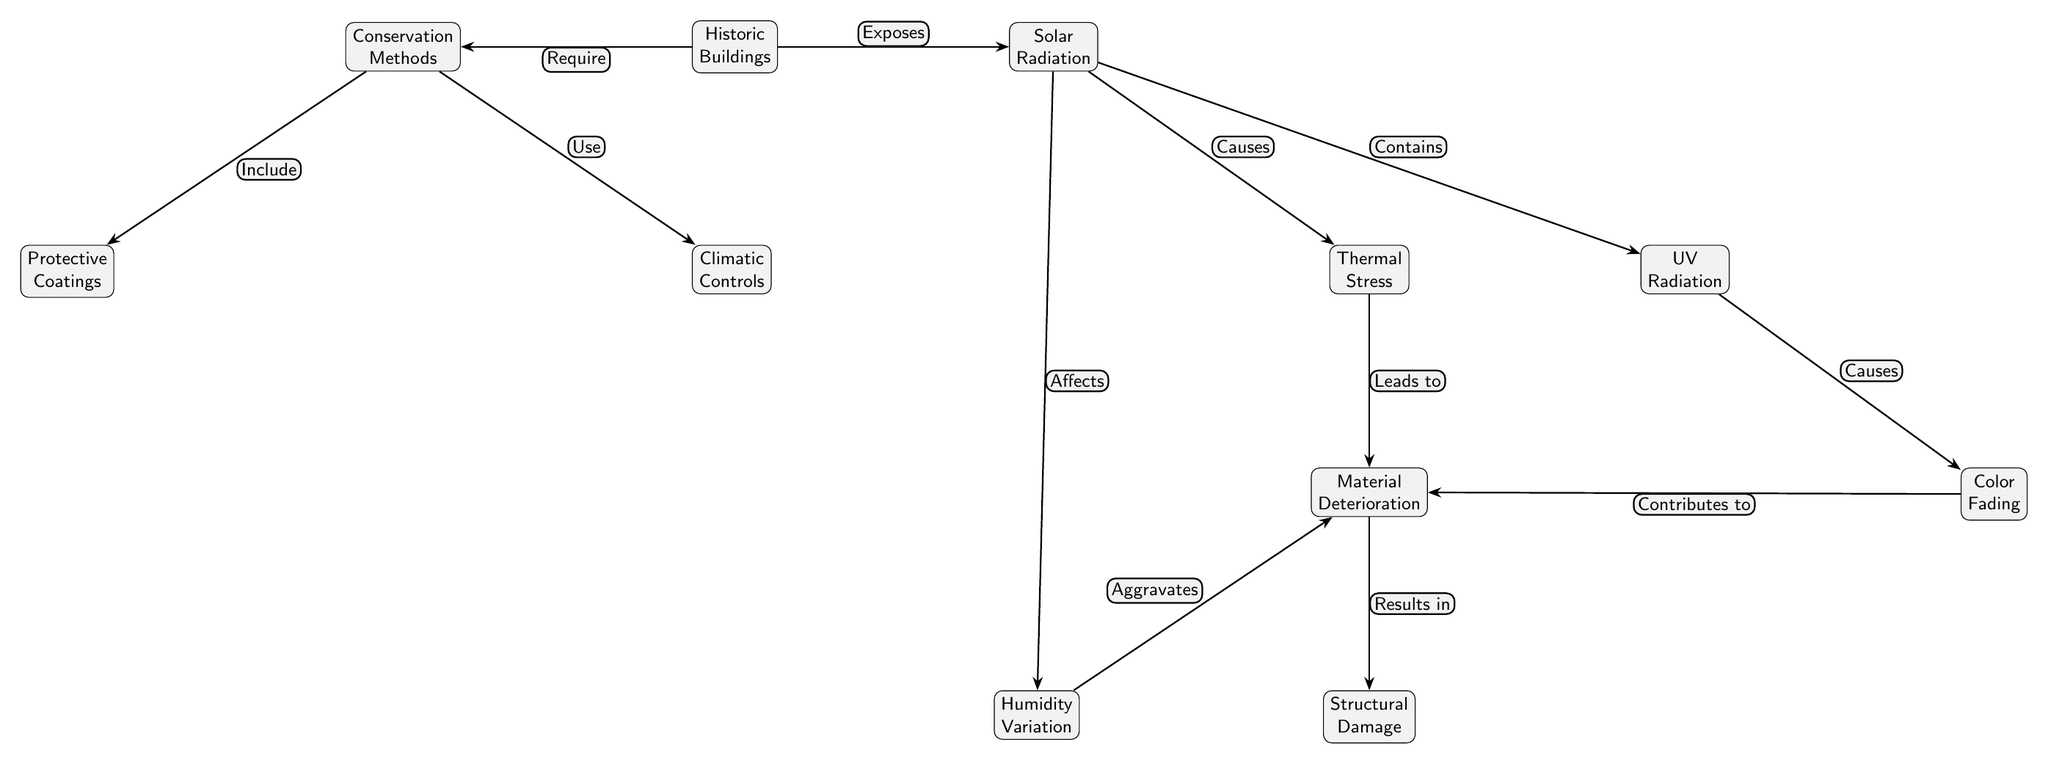What are the two main types of stress caused by solar radiation? The diagram lists thermal stress and UV radiation as the two main types of stress attributed to solar radiation. These are represented as separate nodes connected to the solar radiation node.
Answer: Thermal stress, UV radiation What leads to structural damage? The diagram shows that structural damage results from material deterioration, which is depicted as a node below material deterioration connected with a "Results in" edge label. Material deterioration, notably influenced by thermal stress and humidity variation, leads to structural damage.
Answer: Material deterioration How many conservation methods are shown in the diagram? The diagram presents two conservation methods: protective coatings and climatic controls. These are connected to the conservation methods node with "Include" and "Use" respectively, indicating the means of preservation.
Answer: Two What contributes to material deterioration? According to the diagram, material deterioration is influenced by both humidity variation and color fading. The corresponding edges labeled "Aggravates" and "Contributes to" indicate these relationships to material deterioration.
Answer: Humidity variation, color fading What does solar radiation expose? The diagram describes that solar radiation exposes historic buildings, as shown by the edge labeled "Exposes" connecting the historic buildings and solar radiation nodes. This indicates that historic buildings are directly affected by solar radiation.
Answer: Historic buildings What causes color fading? The diagram explicitly shows that UV radiation causes color fading, as indicated by the edge labeled "Causes" leading from the UV radiation node to the color fading node. This highlights the detrimental effect of UV radiation on the colors of historic buildings.
Answer: UV radiation What is one way to mitigate the impact of solar radiation on historic buildings? The diagram indicates that conservation methods are required for historic buildings to mitigate the effects of solar radiation, which suggests that implementing protective measures is essential for preservation.
Answer: Conservation methods Which factor is shown to aggravate material deterioration? The diagram indicates that humidity variation aggravates material deterioration, shown by the edge labeled "Aggravates" connecting humidity variation to the material deterioration node. This highlights the role of humidity in the deterioration process.
Answer: Humidity variation 